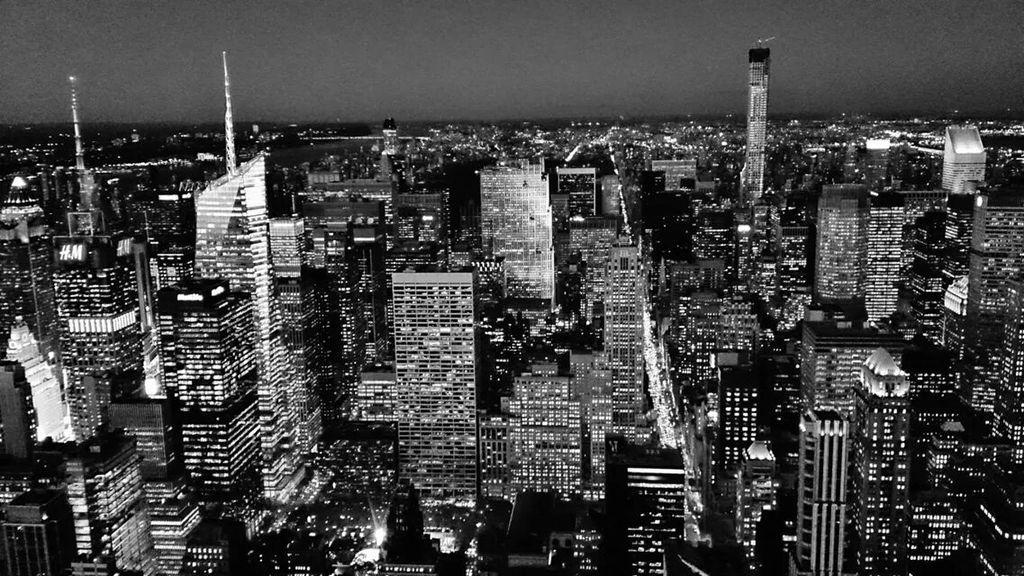Please provide a concise description of this image. In the picture we can see an Ariel view of the city with full of buildings and lights to it and we can also see some tower buildings with many floors and behind it we can see a sky. 